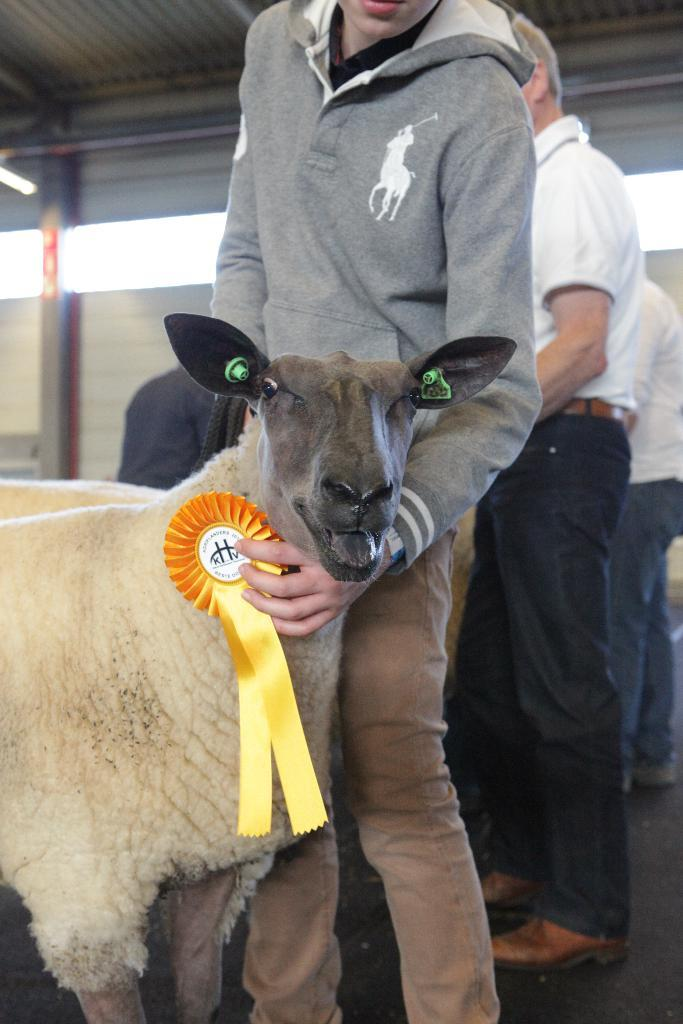What types of living beings are present in the image? There are animals and a group of people in the image. Where are the people and animals located in the image? They are under a shed. What type of screw can be seen on the sidewalk in the image? There is no screw or sidewalk present in the image; it features animals and people under a shed. What key is being used to unlock the door in the image? There is no door or key present in the image; it only shows animals and people under a shed. 